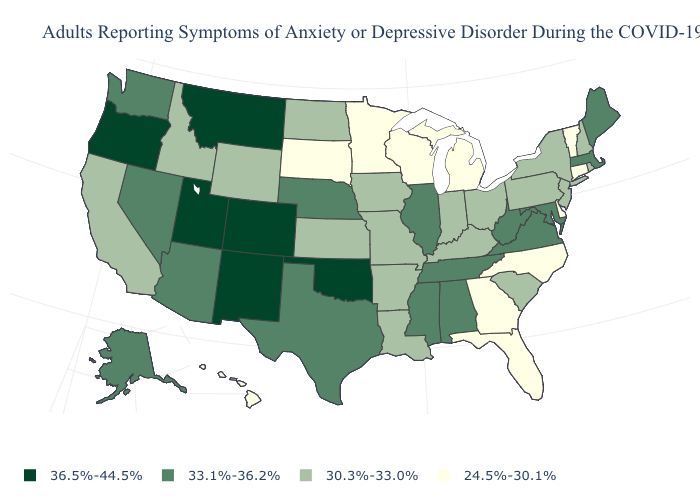What is the value of New Hampshire?
Keep it brief. 30.3%-33.0%. Name the states that have a value in the range 36.5%-44.5%?
Write a very short answer. Colorado, Montana, New Mexico, Oklahoma, Oregon, Utah. What is the lowest value in the MidWest?
Answer briefly. 24.5%-30.1%. What is the value of Vermont?
Keep it brief. 24.5%-30.1%. What is the value of Wyoming?
Concise answer only. 30.3%-33.0%. Is the legend a continuous bar?
Quick response, please. No. What is the value of Minnesota?
Write a very short answer. 24.5%-30.1%. Name the states that have a value in the range 30.3%-33.0%?
Write a very short answer. Arkansas, California, Idaho, Indiana, Iowa, Kansas, Kentucky, Louisiana, Missouri, New Hampshire, New Jersey, New York, North Dakota, Ohio, Pennsylvania, Rhode Island, South Carolina, Wyoming. Name the states that have a value in the range 33.1%-36.2%?
Write a very short answer. Alabama, Alaska, Arizona, Illinois, Maine, Maryland, Massachusetts, Mississippi, Nebraska, Nevada, Tennessee, Texas, Virginia, Washington, West Virginia. What is the highest value in the South ?
Short answer required. 36.5%-44.5%. What is the lowest value in states that border Wisconsin?
Short answer required. 24.5%-30.1%. What is the value of Washington?
Be succinct. 33.1%-36.2%. What is the value of Wyoming?
Keep it brief. 30.3%-33.0%. Does Michigan have a lower value than Idaho?
Give a very brief answer. Yes. What is the value of Delaware?
Write a very short answer. 24.5%-30.1%. 